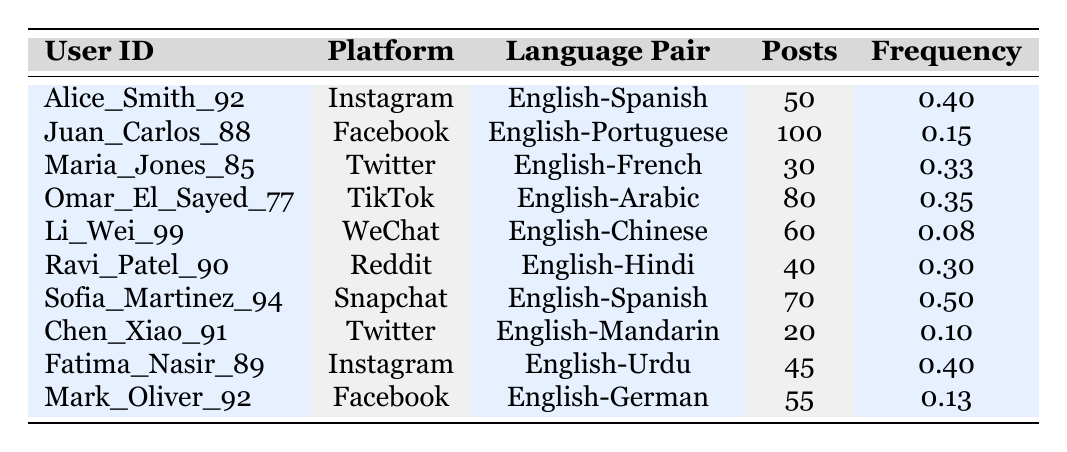What is the highest frequency of code-switching among users? By examining the frequency values listed in the table, we note that Sofia Martinez has a frequency of 0.50, which is the highest among all users.
Answer: 0.50 Which user code-switched the least frequently and what is their frequency? Looking at the table, we see that Li Wei has the lowest frequency of code-switching at 0.08.
Answer: 0.08 How many posts did Juan Carlos make? In the table, the number of posts made by Juan Carlos is clearly indicated as 100.
Answer: 100 What is the total number of posts made by users on Instagram? The table shows that Alice Smith made 50 posts, and Fatima Nasir made 45 posts. Therefore, the total is 50 + 45 = 95 posts.
Answer: 95 Is there any user who code-switched more frequently than 0.40? Upon examining the table, Sofia Martinez has a frequency of 0.50, which confirms that there is at least one user who code-switched more frequently than 0.40.
Answer: Yes Which platform has the highest average frequency of code-switching among its users, and what is that average? For Instagram (users Alice Smith and Fatima Nasir), average is (0.40 + 0.40) / 2 = 0.40. For Facebook (Juan Carlos and Mark Oliver), the average is (0.15 + 0.13) / 2 = 0.14. For TikTok, it's 0.35. For Reddit, it’s 0.30, for Snapchat, it’s 0.50, and for WeChat, it’s 0.08. The highest average is therefore for Snapchat at 0.50.
Answer: Snapchat, 0.50 How many users use English-Spanish as their language pair? The table shows two users (Alice Smith and Sofia Martinez) that are using English-Spanish, which indicates that there are two users.
Answer: 2 What is the difference in post count between users with the highest and lowest frequency of code-switching? Looking at the highest frequency (Sofia Martinez with 70 posts) and the lowest frequency (Li Wei with 60 posts), we find the difference is 70 - 20 = 50 posts.
Answer: 50 Which user had a higher code-switch count, Fatima Nasir or Maria Jones? The code-switch count for Fatima Nasir is 18, while for Maria Jones it is 10. Since 18 is greater than 10, Fatima Nasir had a higher code-switch count.
Answer: Fatima Nasir What percentage of posts did Alice Smith code-switch in her Instagram posts? Alice Smith has a code-switch count of 20 and a post count of 50. Therefore, (20/50) * 100 = 40%, which is her code-switching percentage in posts.
Answer: 40% What can be inferred about the correlation between post count and frequency for users? Analyzing the table shows that there isn't a clear correlation; for instance, Juan Carlos has a high post count but a low frequency, suggesting that post count doesn't necessarily lead to higher frequency.
Answer: No clear correlation 